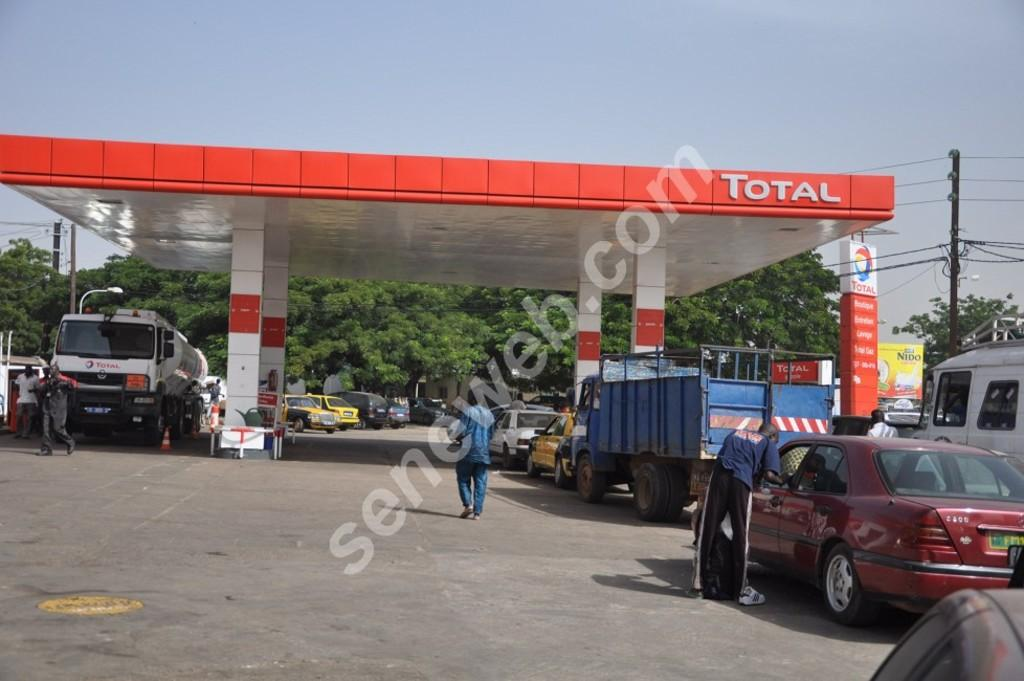What type of establishment is shown in the image? The image depicts a petrol bunk. What else can be seen in the image besides the petrol bunk? There are vehicles on the road, people standing on the road, trees, electric poles, wires, light poles, a house on the left side, and the sky visible in the image. Can you describe the vehicles in the image? The vehicles on the road are not specified in the facts, so we cannot describe them. What is the condition of the sky in the image? The sky is visible in the image, but its condition is not specified in the facts. What type of prose is being recited by the friends in the image? There are no friends or prose present in the image; it depicts a petrol bunk and related elements. 